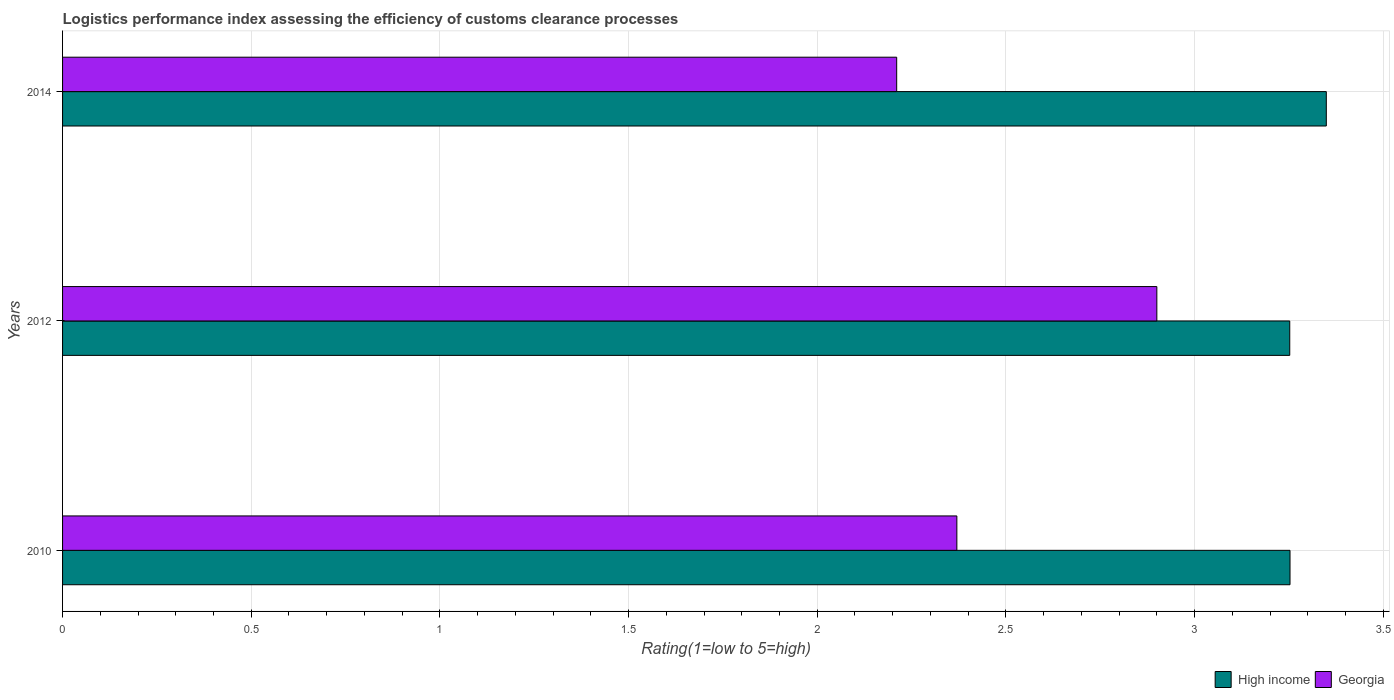Are the number of bars per tick equal to the number of legend labels?
Ensure brevity in your answer.  Yes. Are the number of bars on each tick of the Y-axis equal?
Provide a succinct answer. Yes. How many bars are there on the 3rd tick from the top?
Offer a terse response. 2. What is the Logistic performance index in Georgia in 2010?
Your response must be concise. 2.37. Across all years, what is the maximum Logistic performance index in Georgia?
Your answer should be compact. 2.9. Across all years, what is the minimum Logistic performance index in High income?
Ensure brevity in your answer.  3.25. In which year was the Logistic performance index in Georgia maximum?
Offer a terse response. 2012. In which year was the Logistic performance index in Georgia minimum?
Ensure brevity in your answer.  2014. What is the total Logistic performance index in High income in the graph?
Your response must be concise. 9.85. What is the difference between the Logistic performance index in Georgia in 2012 and that in 2014?
Your response must be concise. 0.69. What is the difference between the Logistic performance index in Georgia in 2010 and the Logistic performance index in High income in 2014?
Offer a very short reply. -0.98. What is the average Logistic performance index in High income per year?
Make the answer very short. 3.28. In the year 2014, what is the difference between the Logistic performance index in Georgia and Logistic performance index in High income?
Provide a short and direct response. -1.14. In how many years, is the Logistic performance index in Georgia greater than 2.8 ?
Provide a short and direct response. 1. What is the ratio of the Logistic performance index in Georgia in 2010 to that in 2014?
Your response must be concise. 1.07. What is the difference between the highest and the second highest Logistic performance index in Georgia?
Offer a very short reply. 0.53. What is the difference between the highest and the lowest Logistic performance index in Georgia?
Ensure brevity in your answer.  0.69. In how many years, is the Logistic performance index in Georgia greater than the average Logistic performance index in Georgia taken over all years?
Your response must be concise. 1. Is the sum of the Logistic performance index in Georgia in 2010 and 2012 greater than the maximum Logistic performance index in High income across all years?
Your answer should be compact. Yes. What does the 1st bar from the top in 2010 represents?
Your answer should be very brief. Georgia. What does the 1st bar from the bottom in 2012 represents?
Keep it short and to the point. High income. How many bars are there?
Provide a short and direct response. 6. How many years are there in the graph?
Ensure brevity in your answer.  3. Does the graph contain any zero values?
Your answer should be compact. No. Where does the legend appear in the graph?
Provide a succinct answer. Bottom right. How many legend labels are there?
Provide a short and direct response. 2. How are the legend labels stacked?
Your answer should be compact. Horizontal. What is the title of the graph?
Ensure brevity in your answer.  Logistics performance index assessing the efficiency of customs clearance processes. Does "Korea (Democratic)" appear as one of the legend labels in the graph?
Give a very brief answer. No. What is the label or title of the X-axis?
Your response must be concise. Rating(1=low to 5=high). What is the label or title of the Y-axis?
Provide a succinct answer. Years. What is the Rating(1=low to 5=high) of High income in 2010?
Keep it short and to the point. 3.25. What is the Rating(1=low to 5=high) of Georgia in 2010?
Your response must be concise. 2.37. What is the Rating(1=low to 5=high) of High income in 2012?
Ensure brevity in your answer.  3.25. What is the Rating(1=low to 5=high) in Georgia in 2012?
Keep it short and to the point. 2.9. What is the Rating(1=low to 5=high) in High income in 2014?
Ensure brevity in your answer.  3.35. What is the Rating(1=low to 5=high) of Georgia in 2014?
Keep it short and to the point. 2.21. Across all years, what is the maximum Rating(1=low to 5=high) in High income?
Your response must be concise. 3.35. Across all years, what is the maximum Rating(1=low to 5=high) of Georgia?
Your response must be concise. 2.9. Across all years, what is the minimum Rating(1=low to 5=high) of High income?
Offer a terse response. 3.25. Across all years, what is the minimum Rating(1=low to 5=high) in Georgia?
Provide a short and direct response. 2.21. What is the total Rating(1=low to 5=high) in High income in the graph?
Your answer should be very brief. 9.85. What is the total Rating(1=low to 5=high) of Georgia in the graph?
Offer a terse response. 7.48. What is the difference between the Rating(1=low to 5=high) in High income in 2010 and that in 2012?
Provide a short and direct response. 0. What is the difference between the Rating(1=low to 5=high) of Georgia in 2010 and that in 2012?
Your answer should be compact. -0.53. What is the difference between the Rating(1=low to 5=high) of High income in 2010 and that in 2014?
Provide a succinct answer. -0.1. What is the difference between the Rating(1=low to 5=high) of Georgia in 2010 and that in 2014?
Give a very brief answer. 0.16. What is the difference between the Rating(1=low to 5=high) in High income in 2012 and that in 2014?
Your answer should be very brief. -0.1. What is the difference between the Rating(1=low to 5=high) of Georgia in 2012 and that in 2014?
Keep it short and to the point. 0.69. What is the difference between the Rating(1=low to 5=high) of High income in 2010 and the Rating(1=low to 5=high) of Georgia in 2012?
Your answer should be very brief. 0.35. What is the difference between the Rating(1=low to 5=high) in High income in 2010 and the Rating(1=low to 5=high) in Georgia in 2014?
Your response must be concise. 1.04. What is the difference between the Rating(1=low to 5=high) of High income in 2012 and the Rating(1=low to 5=high) of Georgia in 2014?
Keep it short and to the point. 1.04. What is the average Rating(1=low to 5=high) of High income per year?
Offer a very short reply. 3.28. What is the average Rating(1=low to 5=high) of Georgia per year?
Give a very brief answer. 2.49. In the year 2010, what is the difference between the Rating(1=low to 5=high) of High income and Rating(1=low to 5=high) of Georgia?
Offer a very short reply. 0.88. In the year 2012, what is the difference between the Rating(1=low to 5=high) in High income and Rating(1=low to 5=high) in Georgia?
Your answer should be compact. 0.35. In the year 2014, what is the difference between the Rating(1=low to 5=high) in High income and Rating(1=low to 5=high) in Georgia?
Give a very brief answer. 1.14. What is the ratio of the Rating(1=low to 5=high) in Georgia in 2010 to that in 2012?
Keep it short and to the point. 0.82. What is the ratio of the Rating(1=low to 5=high) of High income in 2010 to that in 2014?
Offer a very short reply. 0.97. What is the ratio of the Rating(1=low to 5=high) in Georgia in 2010 to that in 2014?
Keep it short and to the point. 1.07. What is the ratio of the Rating(1=low to 5=high) in High income in 2012 to that in 2014?
Your response must be concise. 0.97. What is the ratio of the Rating(1=low to 5=high) of Georgia in 2012 to that in 2014?
Offer a terse response. 1.31. What is the difference between the highest and the second highest Rating(1=low to 5=high) of High income?
Keep it short and to the point. 0.1. What is the difference between the highest and the second highest Rating(1=low to 5=high) of Georgia?
Give a very brief answer. 0.53. What is the difference between the highest and the lowest Rating(1=low to 5=high) of High income?
Provide a short and direct response. 0.1. What is the difference between the highest and the lowest Rating(1=low to 5=high) of Georgia?
Your answer should be very brief. 0.69. 